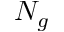Convert formula to latex. <formula><loc_0><loc_0><loc_500><loc_500>N _ { g }</formula> 